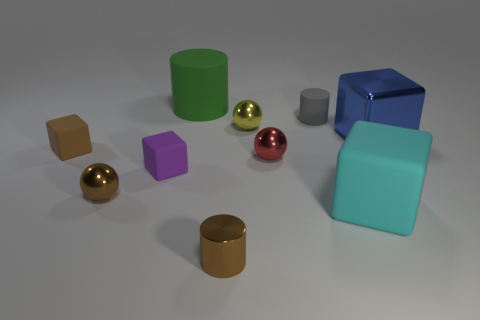What textures are visible on the objects? All objects exhibit a smooth and slightly reflective texture. There's a subtle difference in the reflections on each object, indicating a possible variance in material or surface quality. Do the reflections tell us anything about the light source? Yes, the reflections suggest there's a single, broad light source above and slightly to the right, as indicated by the specular highlights and the shadows cast on the ground. 